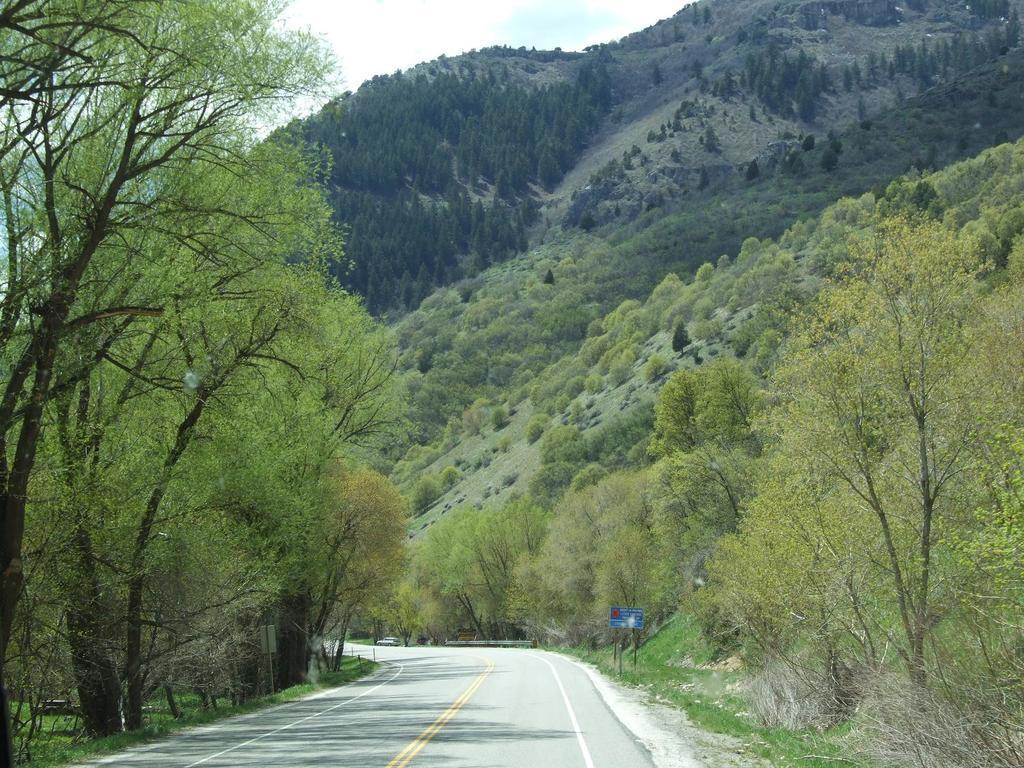Describe this image in one or two sentences. In the picture I can see a road which has few trees on either sides of it and there is a mountain which has few trees on it in the background. 